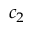Convert formula to latex. <formula><loc_0><loc_0><loc_500><loc_500>c _ { 2 }</formula> 